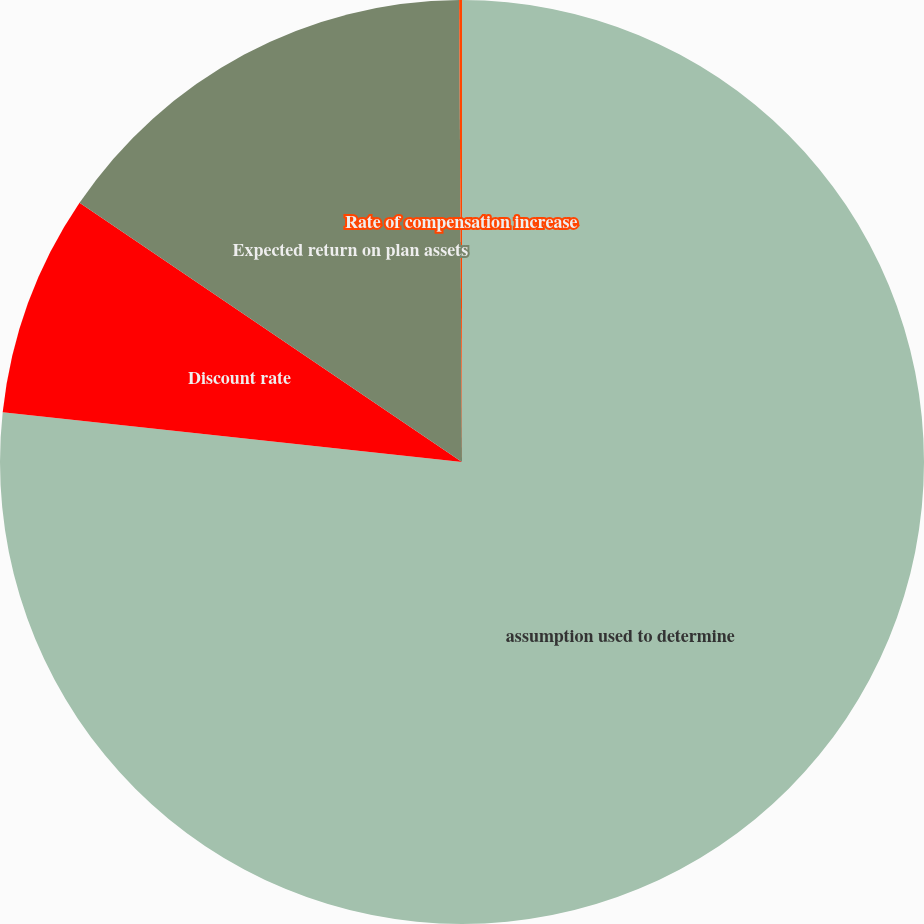Convert chart. <chart><loc_0><loc_0><loc_500><loc_500><pie_chart><fcel>assumption used to determine<fcel>Discount rate<fcel>Expected return on plan assets<fcel>Rate of compensation increase<nl><fcel>76.71%<fcel>7.76%<fcel>15.42%<fcel>0.1%<nl></chart> 